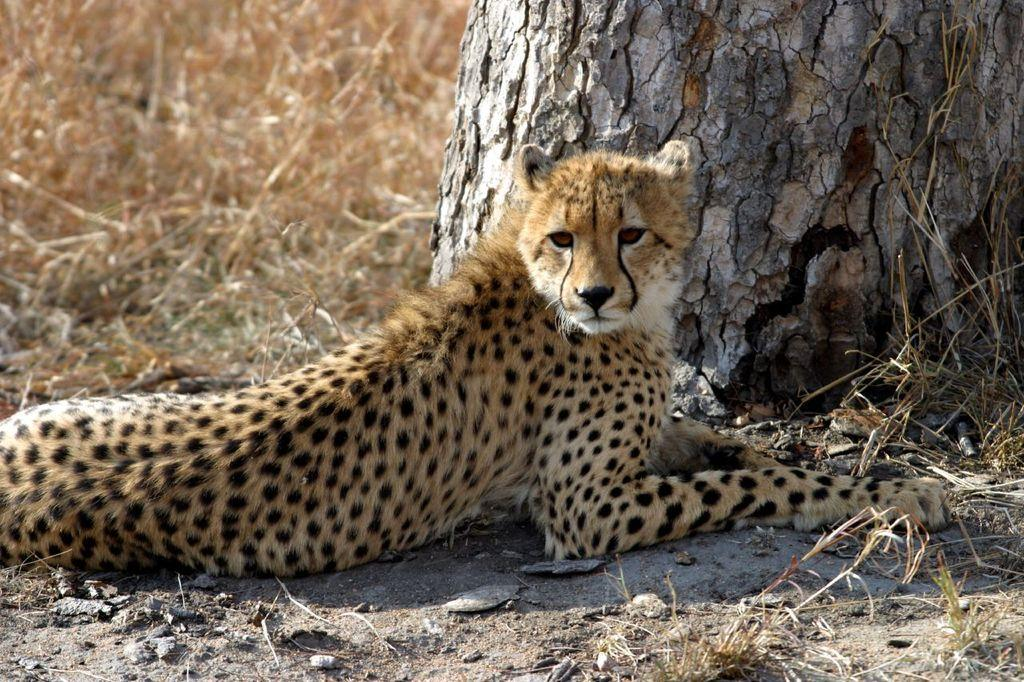What animal is the main subject of the image? There is a tiger in the image. What is the tiger doing in the image? The tiger is sitting on the ground. What other objects or features can be seen in the image? A: There is a tree trunk and grass in the image. What type of collar is the kitten wearing in the image? There is no kitten present in the image, only a tiger. How many eyes does the tiger have in the image? The tiger has two eyes in the image, but we do not need to count them as it is a known fact that tigers have two eyes. 